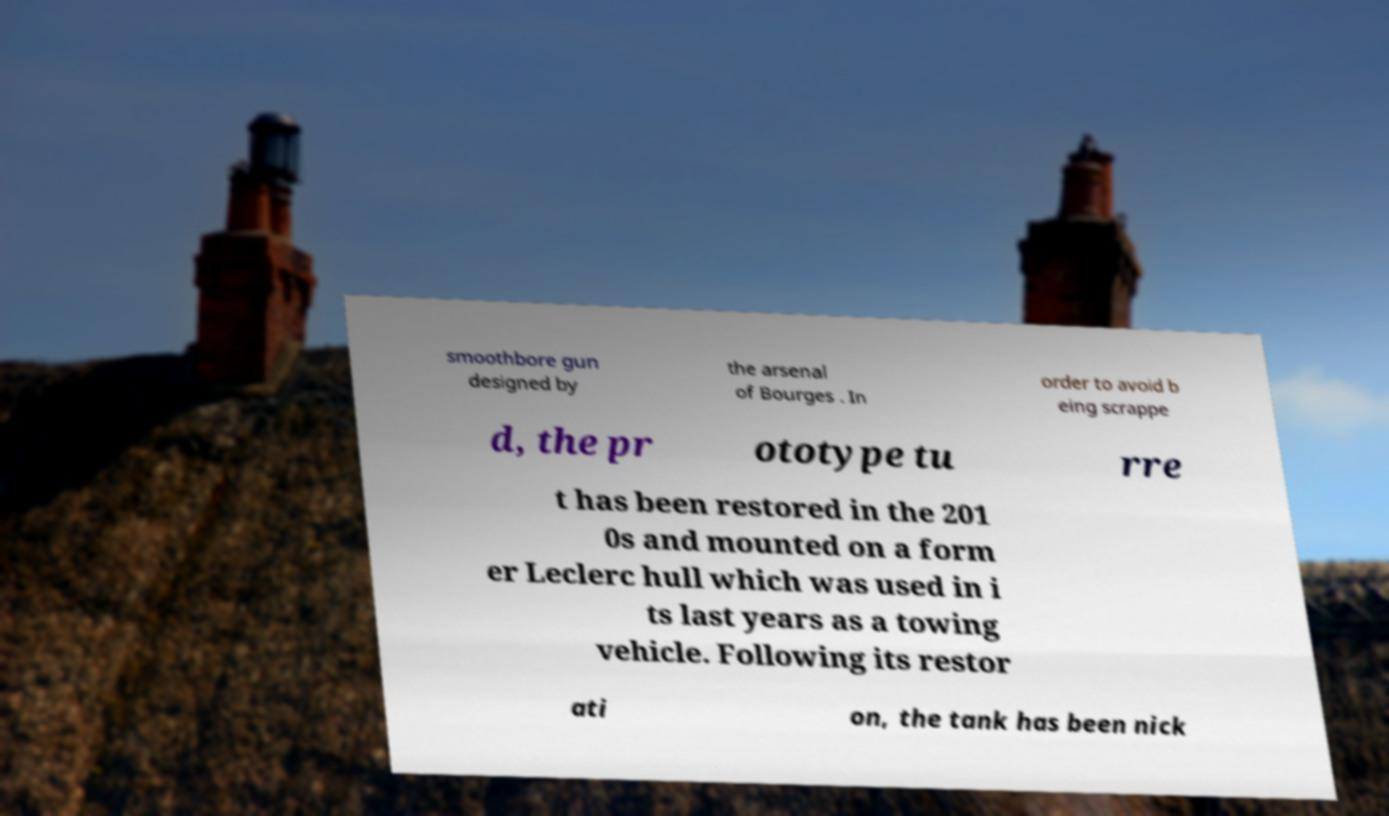Please read and relay the text visible in this image. What does it say? smoothbore gun designed by the arsenal of Bourges . In order to avoid b eing scrappe d, the pr ototype tu rre t has been restored in the 201 0s and mounted on a form er Leclerc hull which was used in i ts last years as a towing vehicle. Following its restor ati on, the tank has been nick 